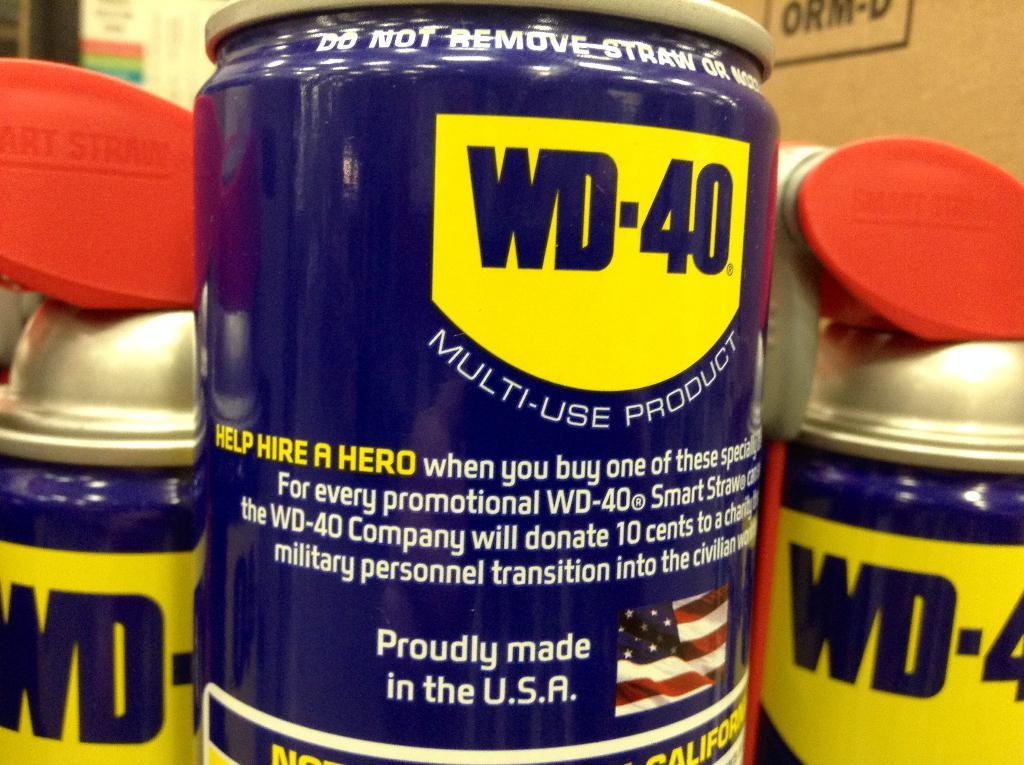Provide a one-sentence caption for the provided image. # cans of WD-40 are shown up close. 